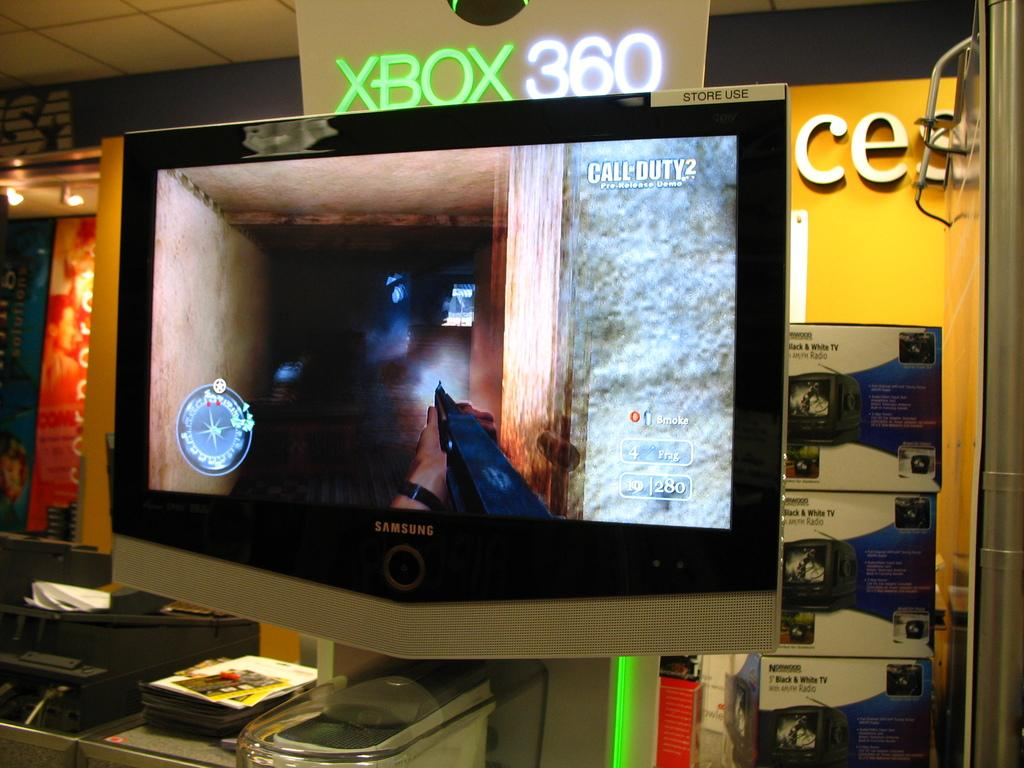Provide a one-sentence caption for the provided image. A screen shows moments of video game play from the XBOX 360. 